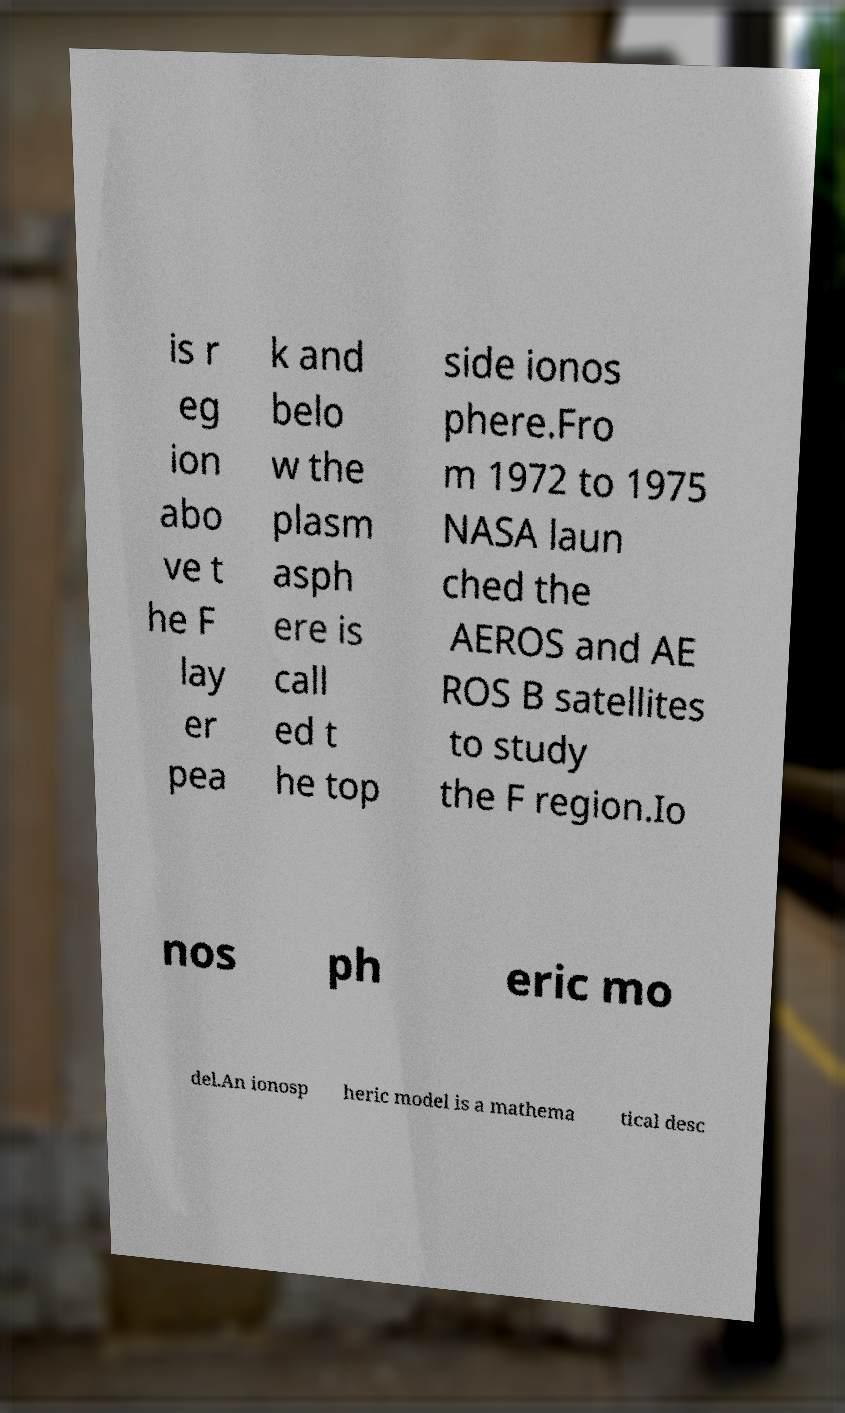Could you extract and type out the text from this image? is r eg ion abo ve t he F lay er pea k and belo w the plasm asph ere is call ed t he top side ionos phere.Fro m 1972 to 1975 NASA laun ched the AEROS and AE ROS B satellites to study the F region.Io nos ph eric mo del.An ionosp heric model is a mathema tical desc 